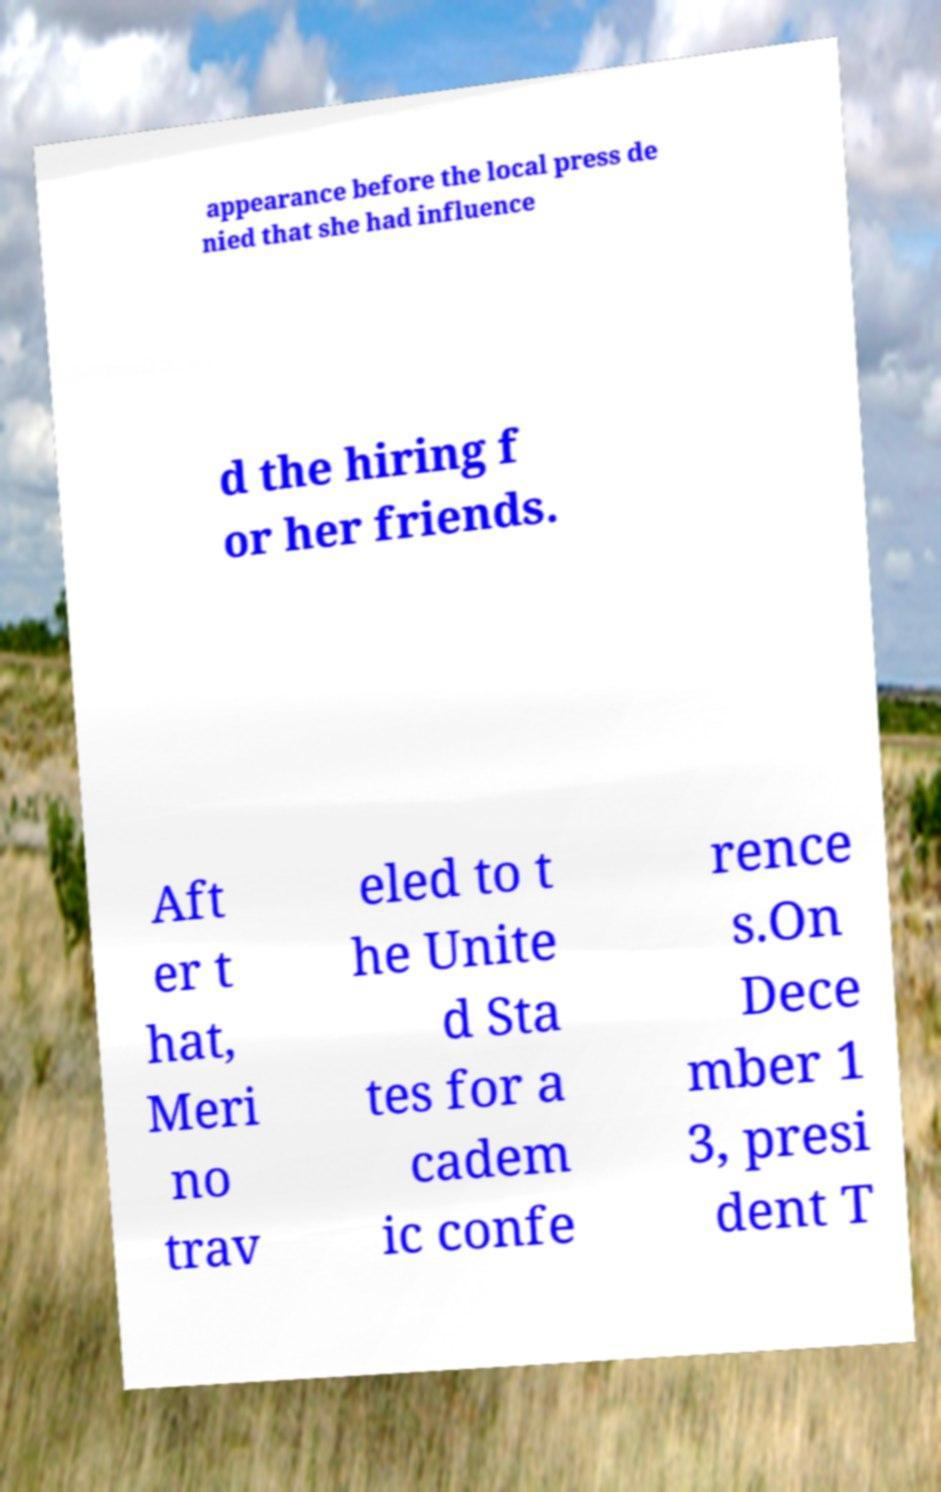Can you read and provide the text displayed in the image?This photo seems to have some interesting text. Can you extract and type it out for me? appearance before the local press de nied that she had influence d the hiring f or her friends. Aft er t hat, Meri no trav eled to t he Unite d Sta tes for a cadem ic confe rence s.On Dece mber 1 3, presi dent T 